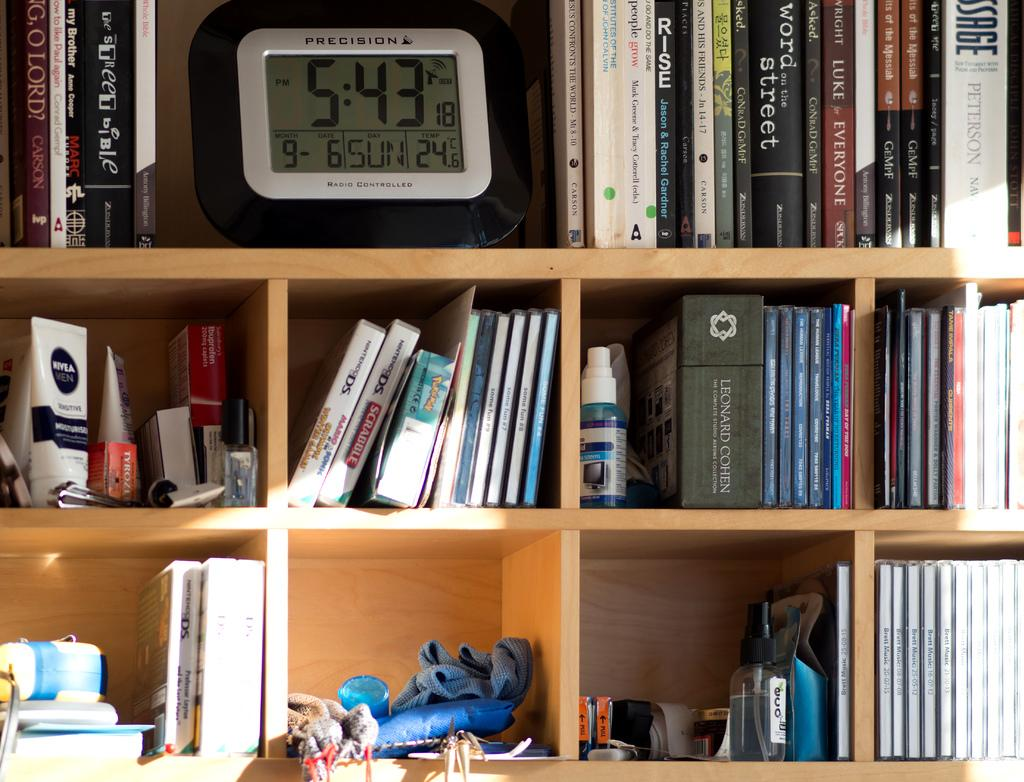<image>
Provide a brief description of the given image. Books and other items are on shelves and a clock reads 5:43. 